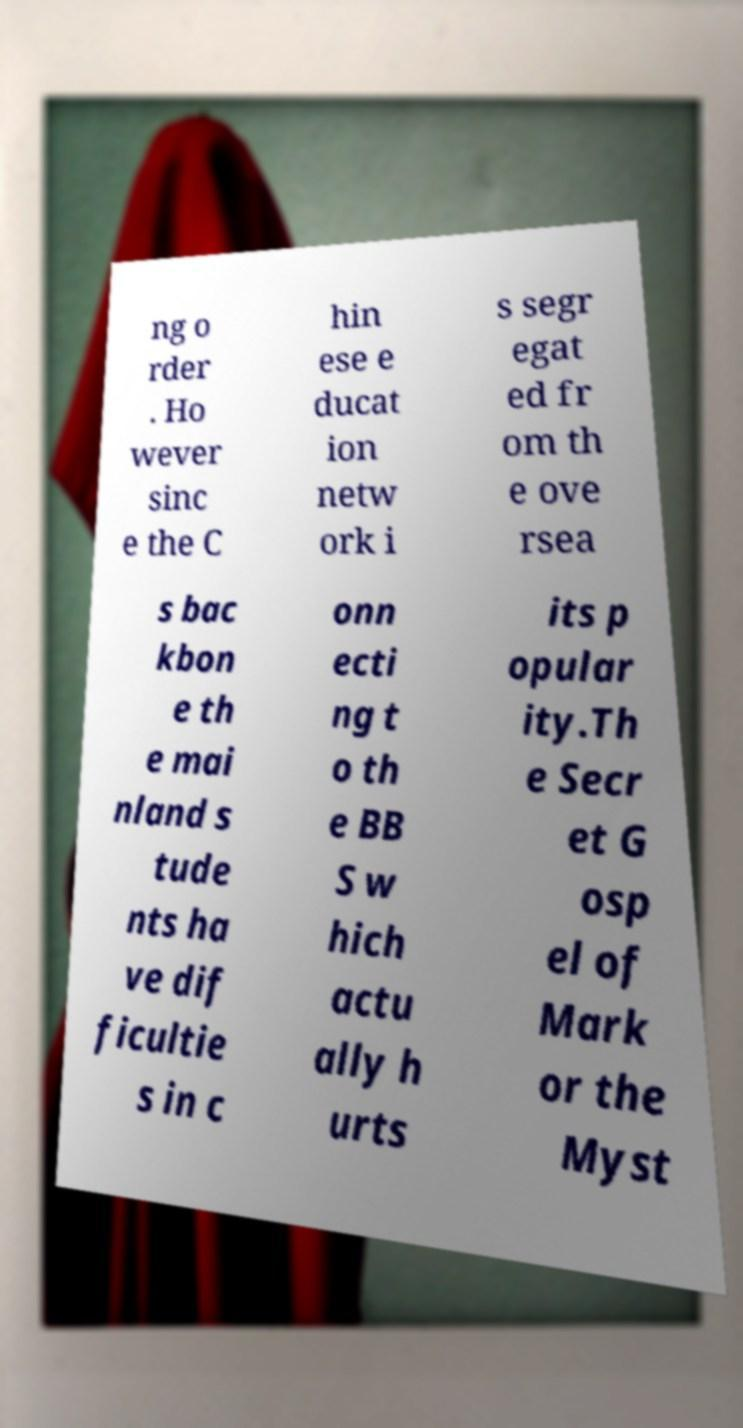Could you assist in decoding the text presented in this image and type it out clearly? ng o rder . Ho wever sinc e the C hin ese e ducat ion netw ork i s segr egat ed fr om th e ove rsea s bac kbon e th e mai nland s tude nts ha ve dif ficultie s in c onn ecti ng t o th e BB S w hich actu ally h urts its p opular ity.Th e Secr et G osp el of Mark or the Myst 